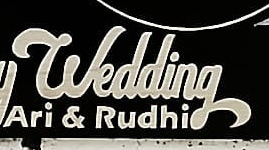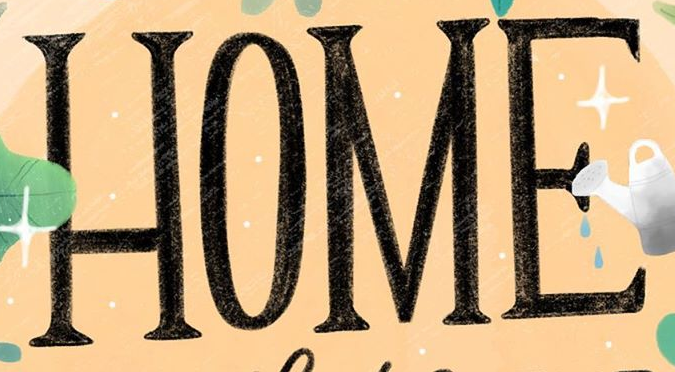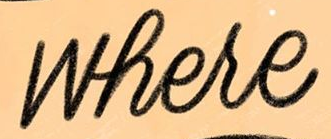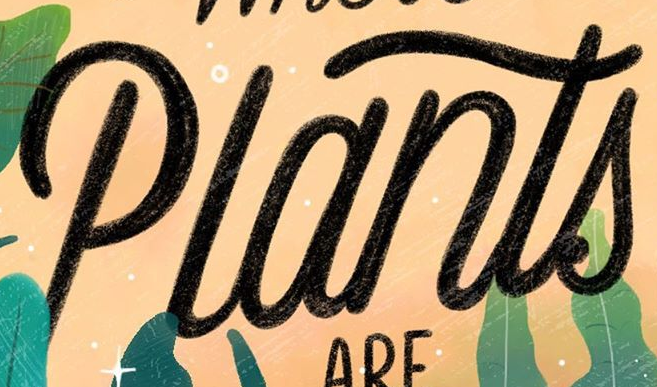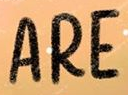What words can you see in these images in sequence, separated by a semicolon? wedding; HOME; where; Plants; ARE 